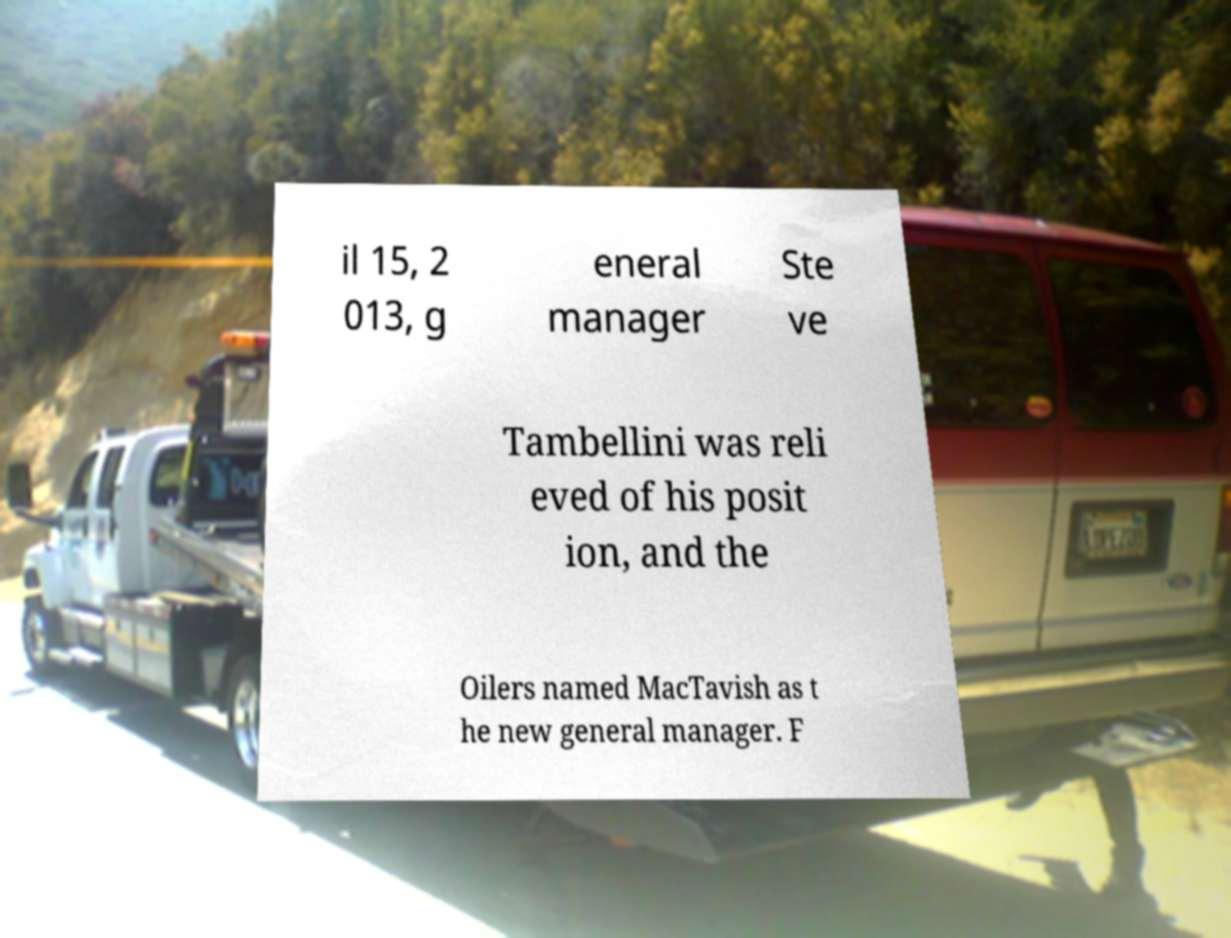Can you accurately transcribe the text from the provided image for me? il 15, 2 013, g eneral manager Ste ve Tambellini was reli eved of his posit ion, and the Oilers named MacTavish as t he new general manager. F 